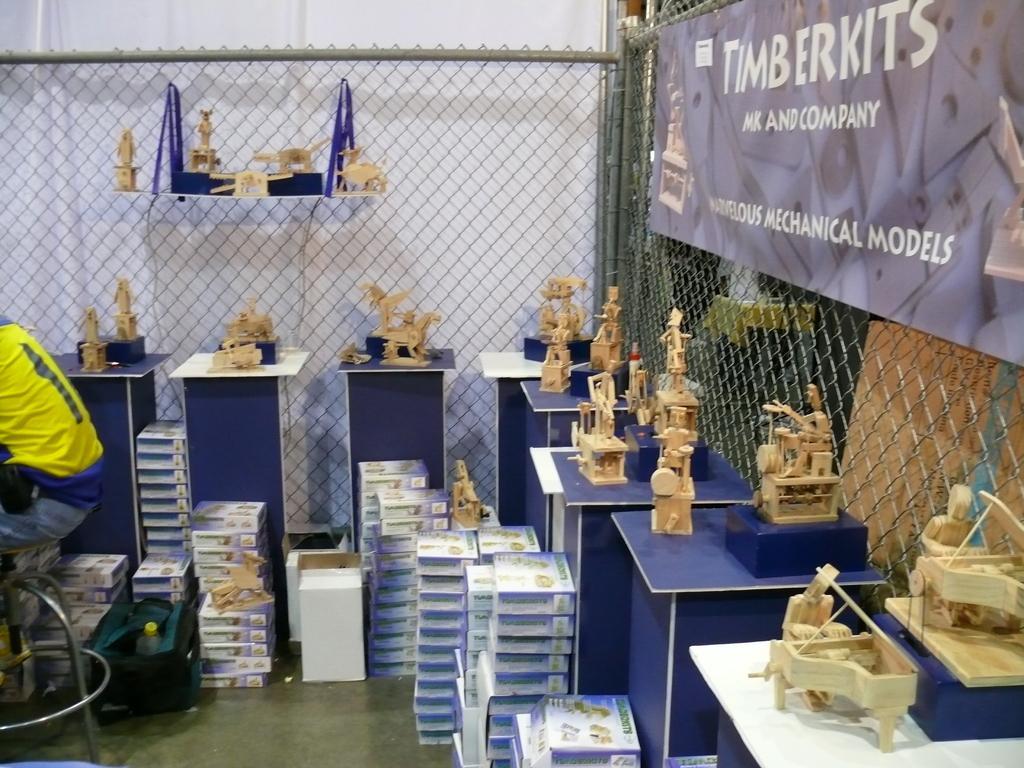Could you give a brief overview of what you see in this image? This picture might be taken in a store, in this image there are some toys, tables, boxes, bag and in the bag there is one bottle. On the left side there is one person who is sitting on chair. in the center and on the right side there is a net. On the right side there is one poster, on the poster there is some text. 